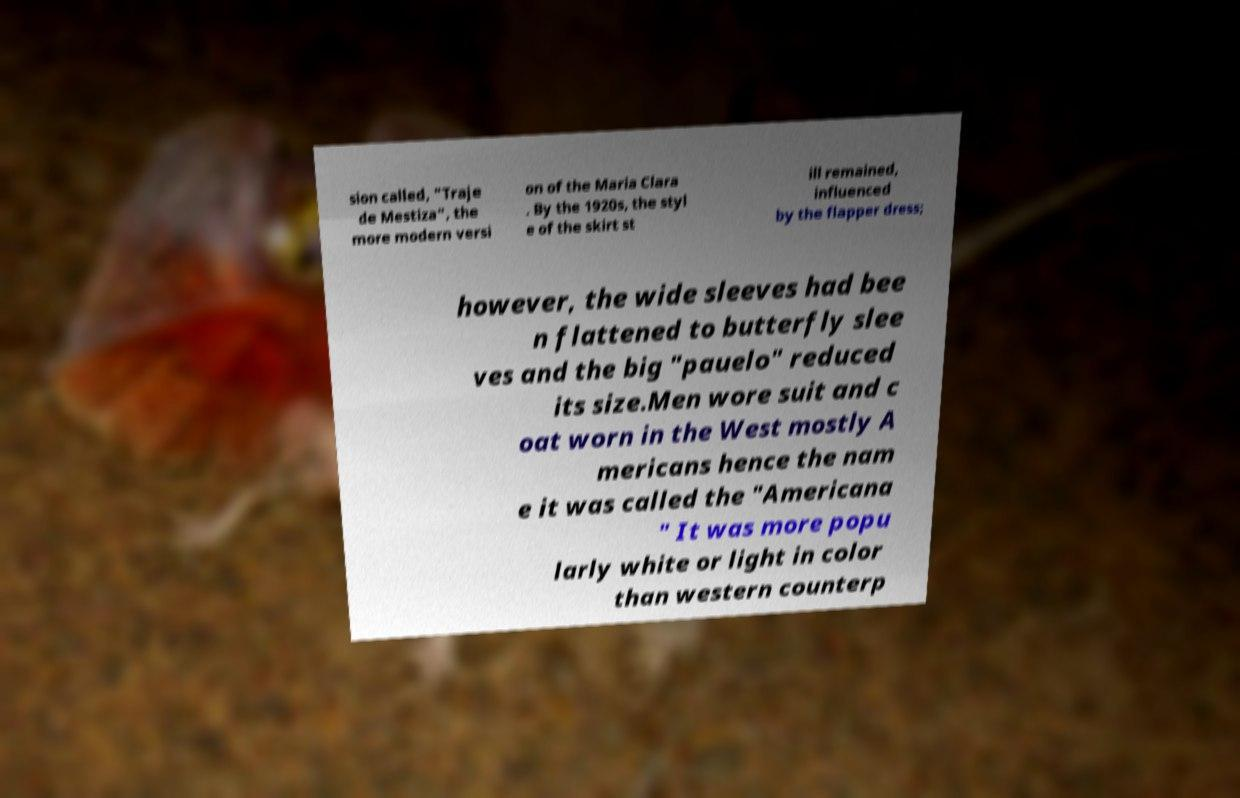What messages or text are displayed in this image? I need them in a readable, typed format. sion called, "Traje de Mestiza", the more modern versi on of the Maria Clara . By the 1920s, the styl e of the skirt st ill remained, influenced by the flapper dress; however, the wide sleeves had bee n flattened to butterfly slee ves and the big "pauelo" reduced its size.Men wore suit and c oat worn in the West mostly A mericans hence the nam e it was called the "Americana " It was more popu larly white or light in color than western counterp 